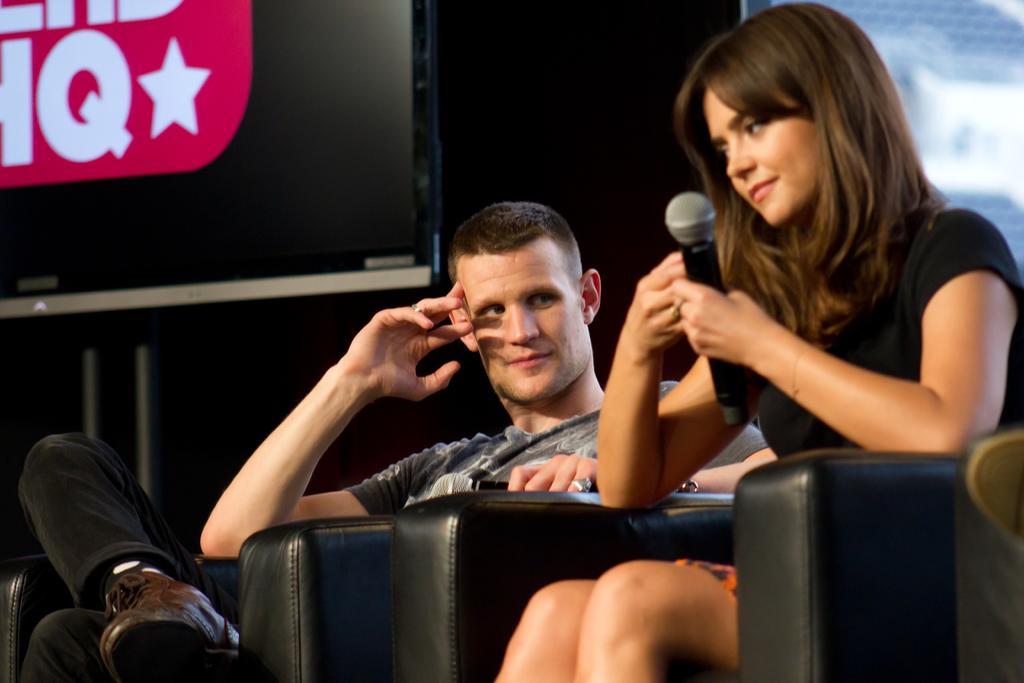Describe this image in one or two sentences. In this picture we can see a man and woman, they are seated, and she is holding a microphone, behind to them we can see a screen and metal rods. 